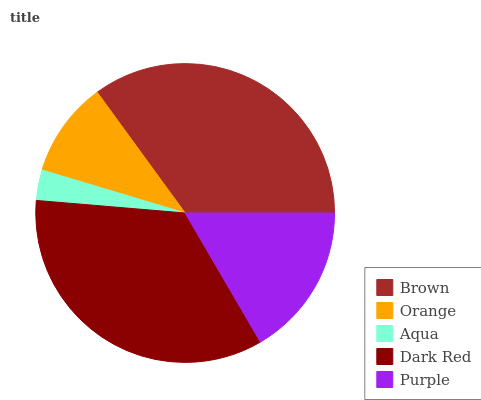Is Aqua the minimum?
Answer yes or no. Yes. Is Brown the maximum?
Answer yes or no. Yes. Is Orange the minimum?
Answer yes or no. No. Is Orange the maximum?
Answer yes or no. No. Is Brown greater than Orange?
Answer yes or no. Yes. Is Orange less than Brown?
Answer yes or no. Yes. Is Orange greater than Brown?
Answer yes or no. No. Is Brown less than Orange?
Answer yes or no. No. Is Purple the high median?
Answer yes or no. Yes. Is Purple the low median?
Answer yes or no. Yes. Is Brown the high median?
Answer yes or no. No. Is Dark Red the low median?
Answer yes or no. No. 